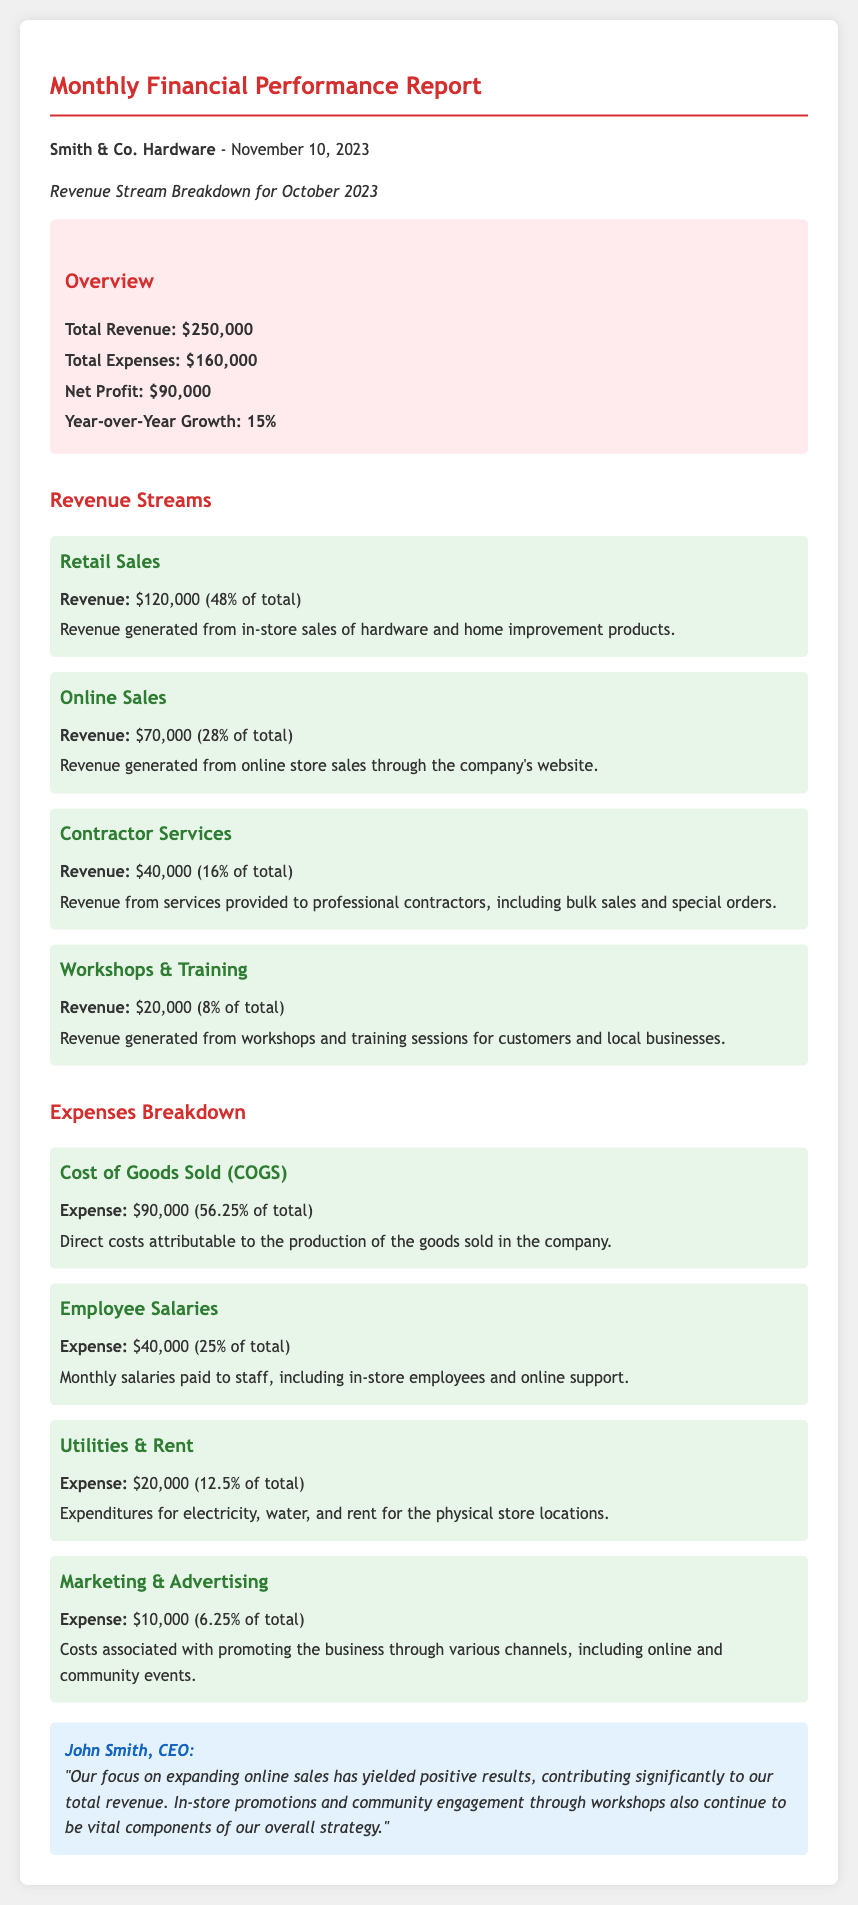What is the total revenue? The total revenue is listed in the overview section of the document, amounting to $250,000.
Answer: $250,000 What percentage of total revenue comes from retail sales? The revenue from retail sales is $120,000, which is stated to be 48% of total revenue.
Answer: 48% What is the net profit reported? The net profit is derived from the total revenue and total expenses, given as $90,000 in the overview.
Answer: $90,000 How much is allocated to employee salaries? The document specifies that employee salaries total $40,000, which is detailed in the expenses breakdown.
Answer: $40,000 What was the year-over-year growth percentage? The overview of the document features the year-over-year growth rate of 15%.
Answer: 15% Which revenue stream contributes the least? Among the listed revenue streams, workshops and training contribute $20,000, making them the least substantial revenue source.
Answer: $20,000 What is the total amount spent on marketing and advertising? The expenses section indicates that the marketing and advertising costs are $10,000.
Answer: $10,000 How much revenue is generated from online sales? The revenue generated from online sales is specifically noted as $70,000 in the revenue streams section.
Answer: $70,000 What are the total expenses reported? Total expenses are summarized in the overview section, amounting to $160,000.
Answer: $160,000 